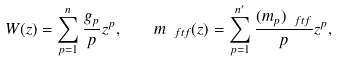<formula> <loc_0><loc_0><loc_500><loc_500>W ( z ) = \sum _ { p = 1 } ^ { n } \frac { g _ { p } } { p } z ^ { p } , \quad m _ { \ f t f } ( z ) = \sum _ { p = 1 } ^ { n ^ { \prime } } \frac { ( m _ { p } ) _ { \ f t f } } { p } z ^ { p } ,</formula> 